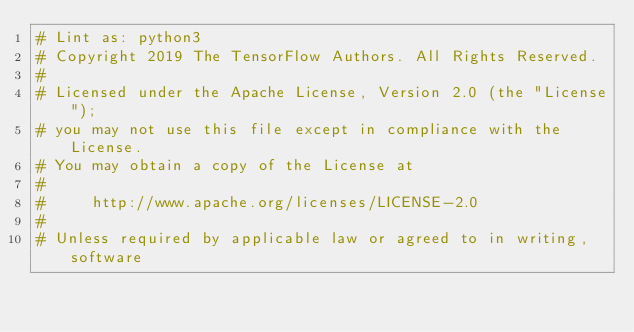<code> <loc_0><loc_0><loc_500><loc_500><_Python_># Lint as: python3
# Copyright 2019 The TensorFlow Authors. All Rights Reserved.
#
# Licensed under the Apache License, Version 2.0 (the "License");
# you may not use this file except in compliance with the License.
# You may obtain a copy of the License at
#
#     http://www.apache.org/licenses/LICENSE-2.0
#
# Unless required by applicable law or agreed to in writing, software</code> 